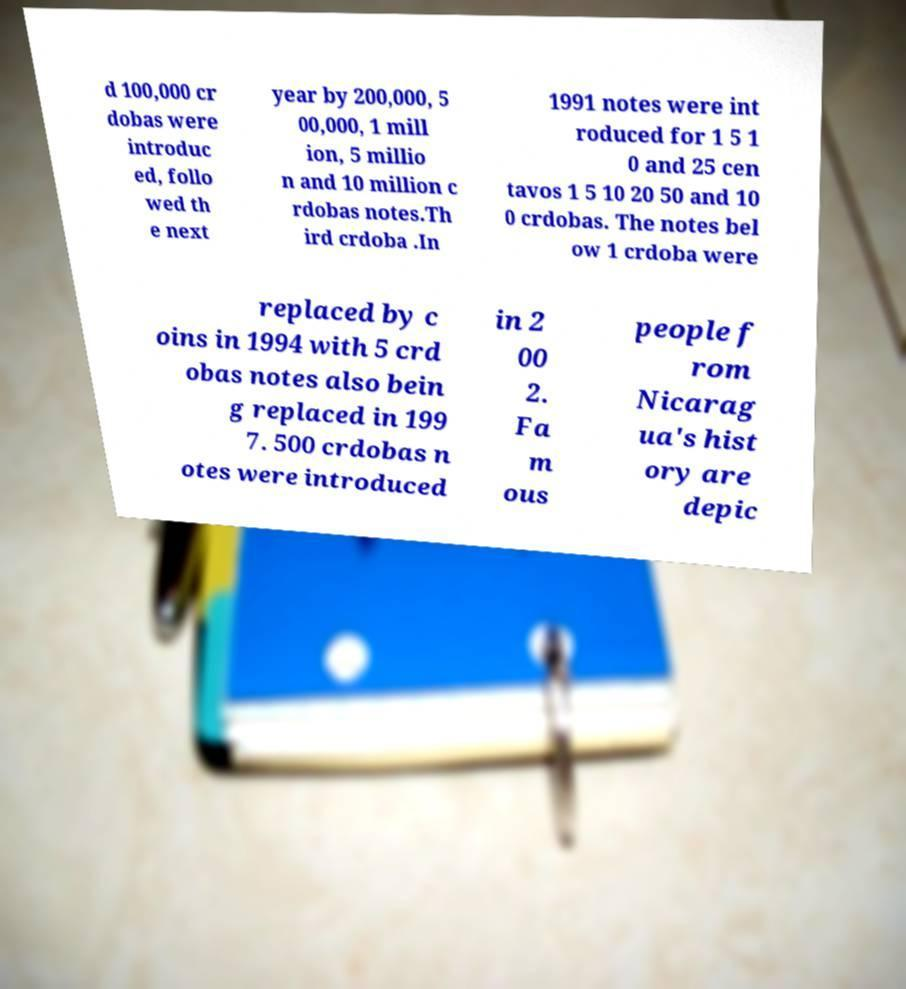What messages or text are displayed in this image? I need them in a readable, typed format. d 100,000 cr dobas were introduc ed, follo wed th e next year by 200,000, 5 00,000, 1 mill ion, 5 millio n and 10 million c rdobas notes.Th ird crdoba .In 1991 notes were int roduced for 1 5 1 0 and 25 cen tavos 1 5 10 20 50 and 10 0 crdobas. The notes bel ow 1 crdoba were replaced by c oins in 1994 with 5 crd obas notes also bein g replaced in 199 7. 500 crdobas n otes were introduced in 2 00 2. Fa m ous people f rom Nicarag ua's hist ory are depic 